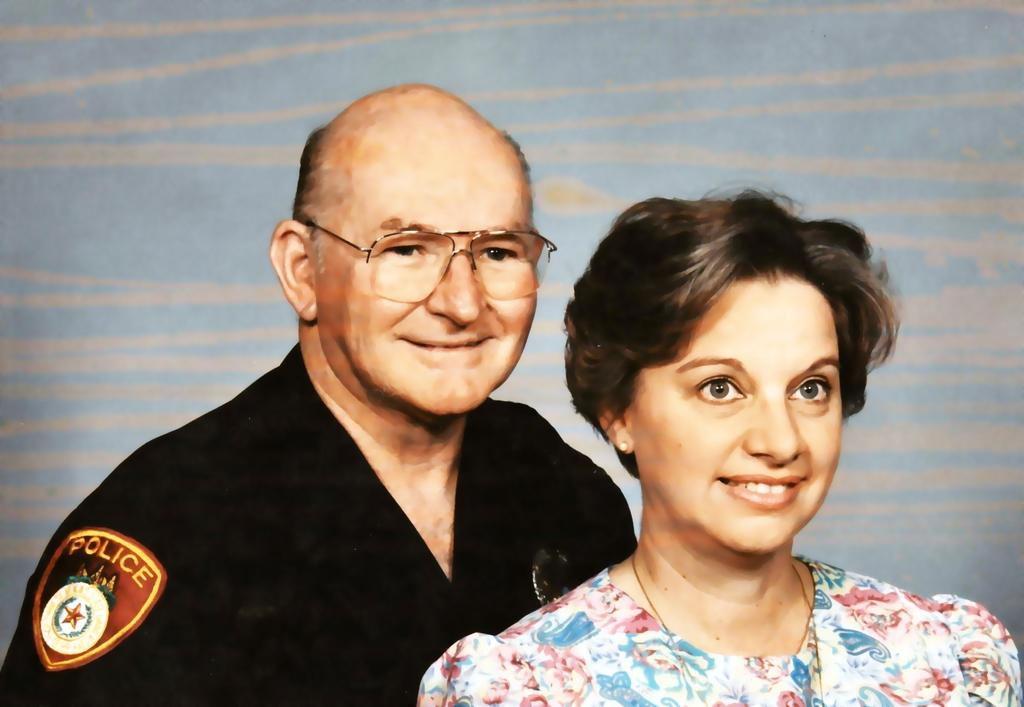How many people are present in the image? There are two persons standing in the image. What can be seen in the background of the image? There is a wall in the background of the image. What type of music is being played in the image? There is no indication of music being played in the image. What shape is the wall in the background of the image? The shape of the wall cannot be determined from the image alone. 